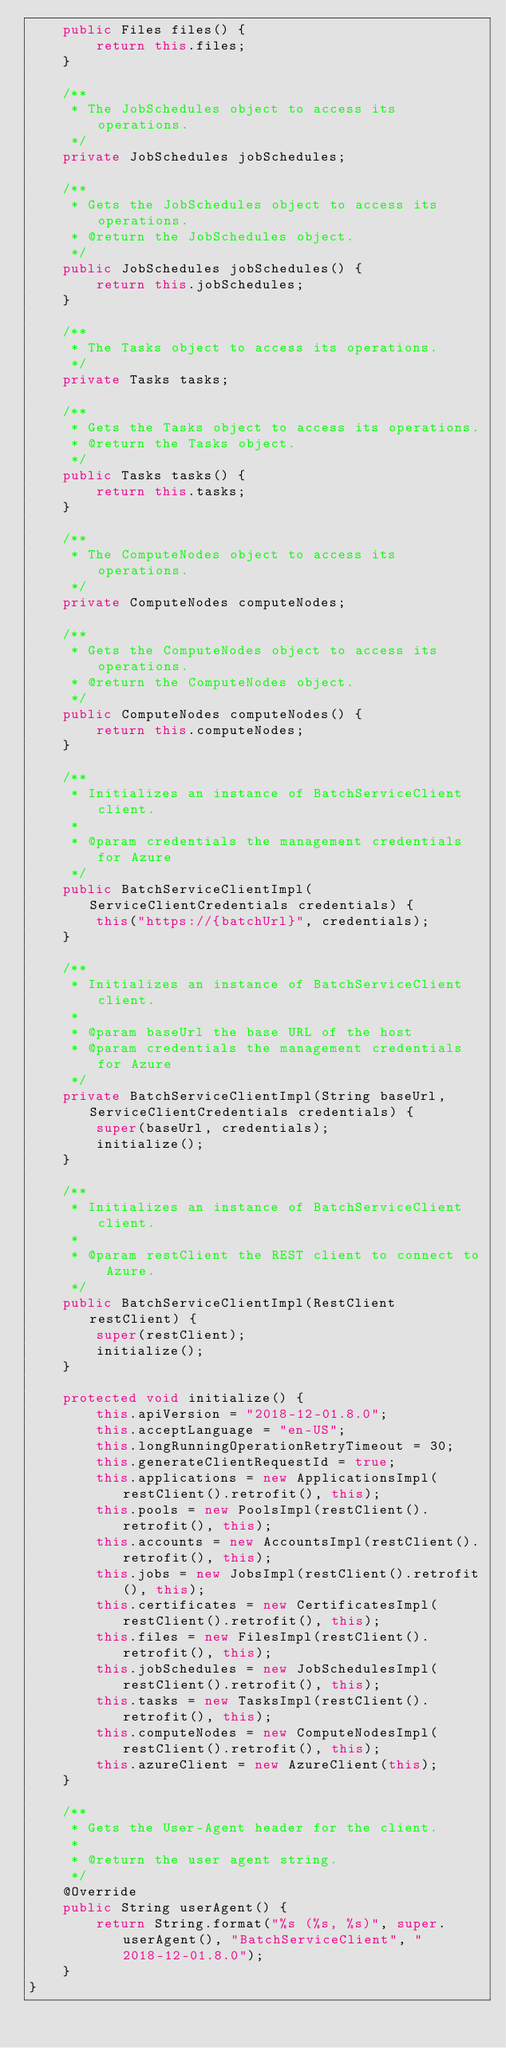<code> <loc_0><loc_0><loc_500><loc_500><_Java_>    public Files files() {
        return this.files;
    }

    /**
     * The JobSchedules object to access its operations.
     */
    private JobSchedules jobSchedules;

    /**
     * Gets the JobSchedules object to access its operations.
     * @return the JobSchedules object.
     */
    public JobSchedules jobSchedules() {
        return this.jobSchedules;
    }

    /**
     * The Tasks object to access its operations.
     */
    private Tasks tasks;

    /**
     * Gets the Tasks object to access its operations.
     * @return the Tasks object.
     */
    public Tasks tasks() {
        return this.tasks;
    }

    /**
     * The ComputeNodes object to access its operations.
     */
    private ComputeNodes computeNodes;

    /**
     * Gets the ComputeNodes object to access its operations.
     * @return the ComputeNodes object.
     */
    public ComputeNodes computeNodes() {
        return this.computeNodes;
    }

    /**
     * Initializes an instance of BatchServiceClient client.
     *
     * @param credentials the management credentials for Azure
     */
    public BatchServiceClientImpl(ServiceClientCredentials credentials) {
        this("https://{batchUrl}", credentials);
    }

    /**
     * Initializes an instance of BatchServiceClient client.
     *
     * @param baseUrl the base URL of the host
     * @param credentials the management credentials for Azure
     */
    private BatchServiceClientImpl(String baseUrl, ServiceClientCredentials credentials) {
        super(baseUrl, credentials);
        initialize();
    }

    /**
     * Initializes an instance of BatchServiceClient client.
     *
     * @param restClient the REST client to connect to Azure.
     */
    public BatchServiceClientImpl(RestClient restClient) {
        super(restClient);
        initialize();
    }

    protected void initialize() {
        this.apiVersion = "2018-12-01.8.0";
        this.acceptLanguage = "en-US";
        this.longRunningOperationRetryTimeout = 30;
        this.generateClientRequestId = true;
        this.applications = new ApplicationsImpl(restClient().retrofit(), this);
        this.pools = new PoolsImpl(restClient().retrofit(), this);
        this.accounts = new AccountsImpl(restClient().retrofit(), this);
        this.jobs = new JobsImpl(restClient().retrofit(), this);
        this.certificates = new CertificatesImpl(restClient().retrofit(), this);
        this.files = new FilesImpl(restClient().retrofit(), this);
        this.jobSchedules = new JobSchedulesImpl(restClient().retrofit(), this);
        this.tasks = new TasksImpl(restClient().retrofit(), this);
        this.computeNodes = new ComputeNodesImpl(restClient().retrofit(), this);
        this.azureClient = new AzureClient(this);
    }

    /**
     * Gets the User-Agent header for the client.
     *
     * @return the user agent string.
     */
    @Override
    public String userAgent() {
        return String.format("%s (%s, %s)", super.userAgent(), "BatchServiceClient", "2018-12-01.8.0");
    }
}
</code> 